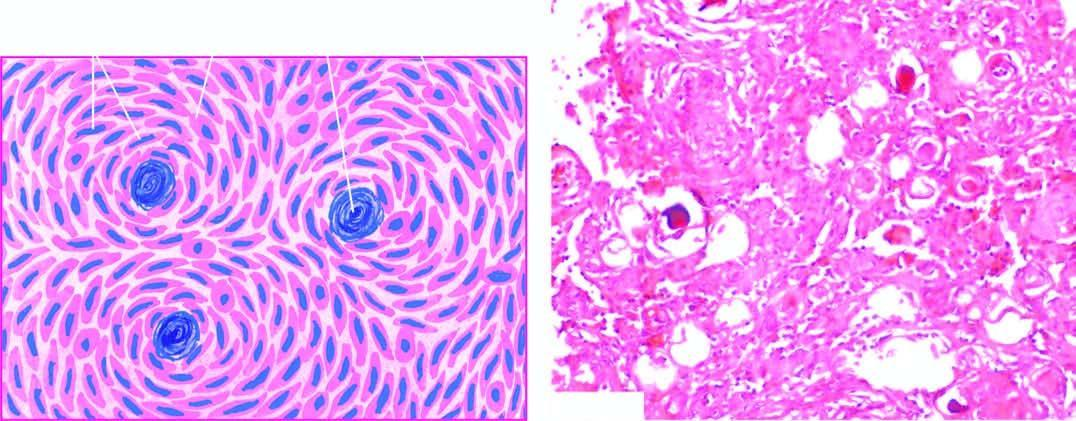do the tips of dermal papillae have features of both syncytial and fibroblastic type and form whorled appearance?
Answer the question using a single word or phrase. No 